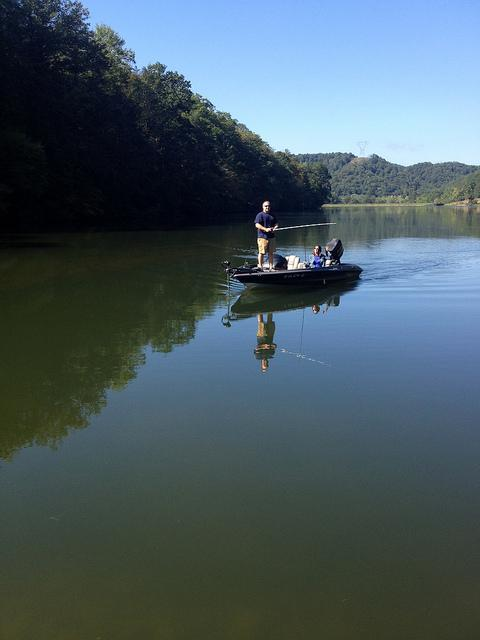How many people are sitting in the fishing boat on this day?

Choices:
A) three
B) four
C) two
D) one two 